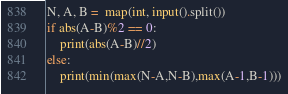Convert code to text. <code><loc_0><loc_0><loc_500><loc_500><_Python_>N, A, B =  map(int, input().split())
if abs(A-B)%2 == 0:
    print(abs(A-B)//2)
else:
    print(min(max(N-A,N-B),max(A-1,B-1)))</code> 